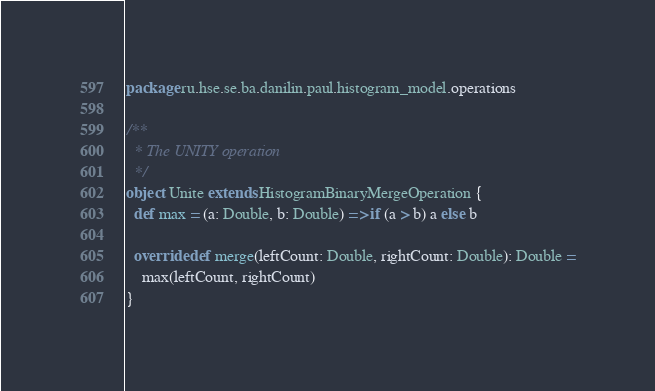<code> <loc_0><loc_0><loc_500><loc_500><_Scala_>package ru.hse.se.ba.danilin.paul.histogram_model.operations

/**
  * The UNITY operation
  */
object Unite extends HistogramBinaryMergeOperation {
  def max = (a: Double, b: Double) => if (a > b) a else b

  override def merge(leftCount: Double, rightCount: Double): Double =
    max(leftCount, rightCount)
}
</code> 